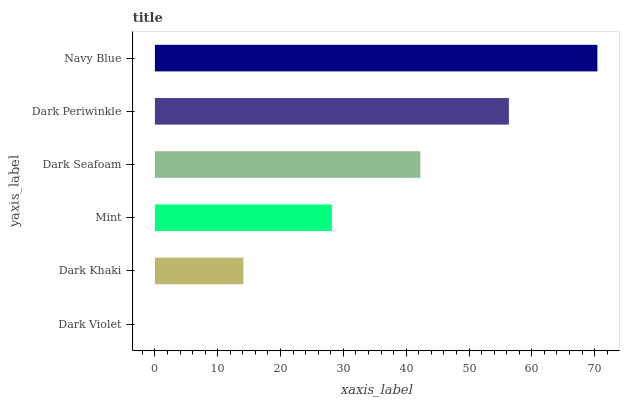Is Dark Violet the minimum?
Answer yes or no. Yes. Is Navy Blue the maximum?
Answer yes or no. Yes. Is Dark Khaki the minimum?
Answer yes or no. No. Is Dark Khaki the maximum?
Answer yes or no. No. Is Dark Khaki greater than Dark Violet?
Answer yes or no. Yes. Is Dark Violet less than Dark Khaki?
Answer yes or no. Yes. Is Dark Violet greater than Dark Khaki?
Answer yes or no. No. Is Dark Khaki less than Dark Violet?
Answer yes or no. No. Is Dark Seafoam the high median?
Answer yes or no. Yes. Is Mint the low median?
Answer yes or no. Yes. Is Navy Blue the high median?
Answer yes or no. No. Is Dark Seafoam the low median?
Answer yes or no. No. 